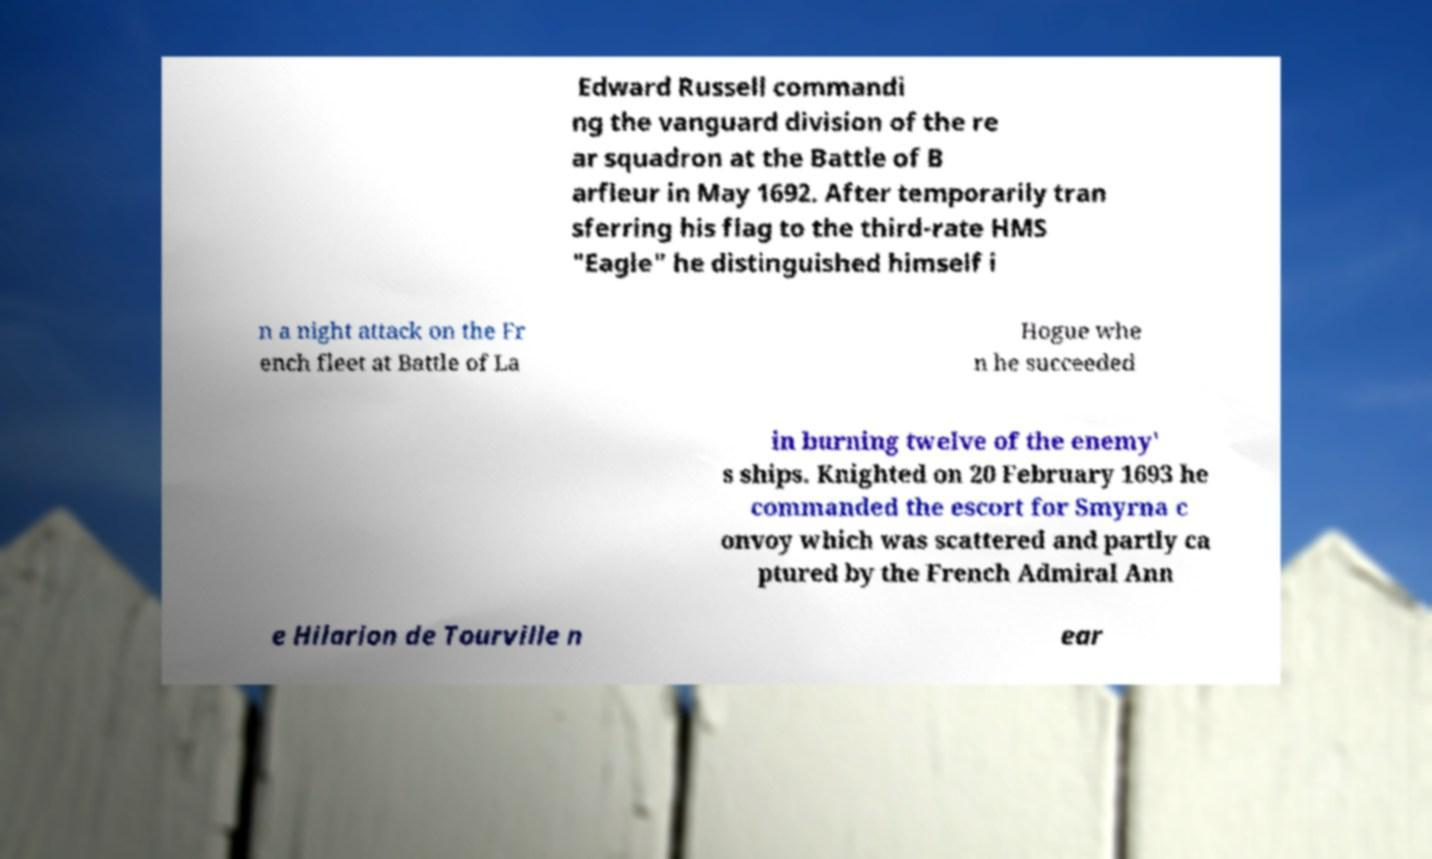There's text embedded in this image that I need extracted. Can you transcribe it verbatim? Edward Russell commandi ng the vanguard division of the re ar squadron at the Battle of B arfleur in May 1692. After temporarily tran sferring his flag to the third-rate HMS "Eagle" he distinguished himself i n a night attack on the Fr ench fleet at Battle of La Hogue whe n he succeeded in burning twelve of the enemy' s ships. Knighted on 20 February 1693 he commanded the escort for Smyrna c onvoy which was scattered and partly ca ptured by the French Admiral Ann e Hilarion de Tourville n ear 